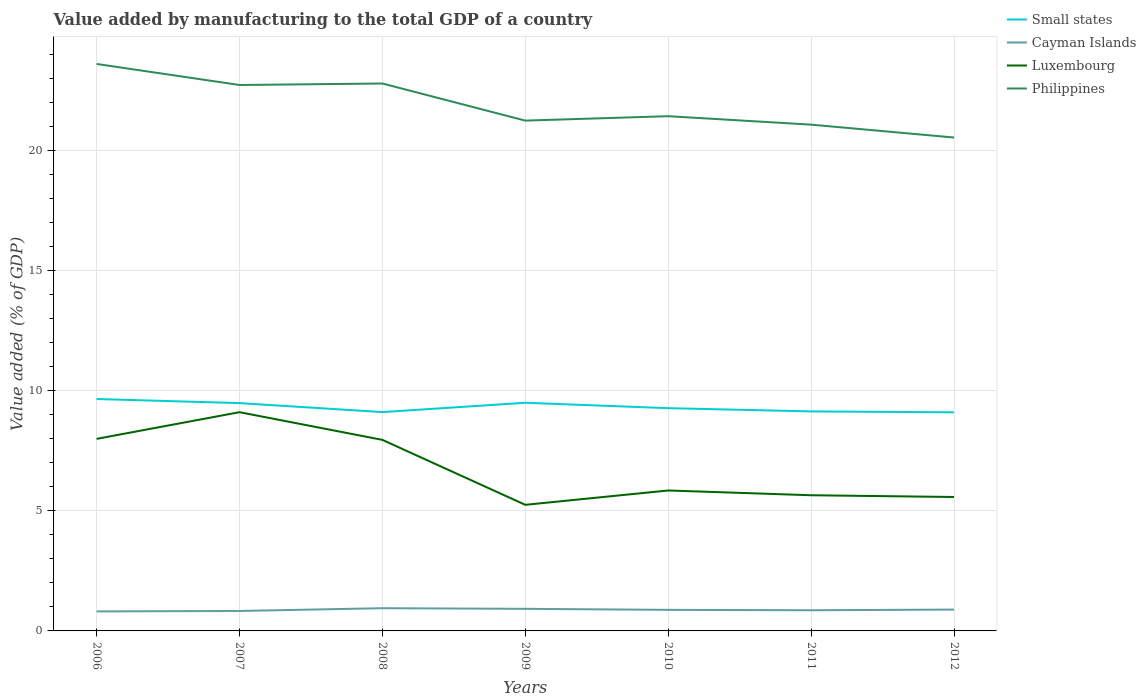How many different coloured lines are there?
Make the answer very short. 4. Does the line corresponding to Cayman Islands intersect with the line corresponding to Luxembourg?
Provide a succinct answer. No. Across all years, what is the maximum value added by manufacturing to the total GDP in Small states?
Keep it short and to the point. 9.11. What is the total value added by manufacturing to the total GDP in Cayman Islands in the graph?
Your answer should be very brief. -0.11. What is the difference between the highest and the second highest value added by manufacturing to the total GDP in Small states?
Ensure brevity in your answer.  0.55. Are the values on the major ticks of Y-axis written in scientific E-notation?
Your response must be concise. No. Does the graph contain any zero values?
Provide a succinct answer. No. Does the graph contain grids?
Provide a succinct answer. Yes. Where does the legend appear in the graph?
Offer a very short reply. Top right. How many legend labels are there?
Ensure brevity in your answer.  4. How are the legend labels stacked?
Keep it short and to the point. Vertical. What is the title of the graph?
Keep it short and to the point. Value added by manufacturing to the total GDP of a country. What is the label or title of the Y-axis?
Make the answer very short. Value added (% of GDP). What is the Value added (% of GDP) of Small states in 2006?
Offer a very short reply. 9.66. What is the Value added (% of GDP) of Cayman Islands in 2006?
Your answer should be compact. 0.81. What is the Value added (% of GDP) in Luxembourg in 2006?
Offer a terse response. 8. What is the Value added (% of GDP) of Philippines in 2006?
Your response must be concise. 23.62. What is the Value added (% of GDP) of Small states in 2007?
Give a very brief answer. 9.49. What is the Value added (% of GDP) in Cayman Islands in 2007?
Ensure brevity in your answer.  0.83. What is the Value added (% of GDP) in Luxembourg in 2007?
Offer a terse response. 9.11. What is the Value added (% of GDP) in Philippines in 2007?
Give a very brief answer. 22.74. What is the Value added (% of GDP) in Small states in 2008?
Give a very brief answer. 9.12. What is the Value added (% of GDP) in Cayman Islands in 2008?
Give a very brief answer. 0.95. What is the Value added (% of GDP) in Luxembourg in 2008?
Your answer should be very brief. 7.96. What is the Value added (% of GDP) of Philippines in 2008?
Give a very brief answer. 22.81. What is the Value added (% of GDP) of Small states in 2009?
Ensure brevity in your answer.  9.51. What is the Value added (% of GDP) in Cayman Islands in 2009?
Your response must be concise. 0.92. What is the Value added (% of GDP) in Luxembourg in 2009?
Make the answer very short. 5.25. What is the Value added (% of GDP) in Philippines in 2009?
Ensure brevity in your answer.  21.26. What is the Value added (% of GDP) in Small states in 2010?
Keep it short and to the point. 9.28. What is the Value added (% of GDP) in Cayman Islands in 2010?
Your response must be concise. 0.88. What is the Value added (% of GDP) in Luxembourg in 2010?
Your answer should be very brief. 5.85. What is the Value added (% of GDP) of Philippines in 2010?
Your response must be concise. 21.44. What is the Value added (% of GDP) of Small states in 2011?
Provide a succinct answer. 9.15. What is the Value added (% of GDP) in Cayman Islands in 2011?
Make the answer very short. 0.86. What is the Value added (% of GDP) of Luxembourg in 2011?
Keep it short and to the point. 5.65. What is the Value added (% of GDP) in Philippines in 2011?
Your answer should be compact. 21.09. What is the Value added (% of GDP) in Small states in 2012?
Your answer should be compact. 9.11. What is the Value added (% of GDP) in Cayman Islands in 2012?
Ensure brevity in your answer.  0.89. What is the Value added (% of GDP) in Luxembourg in 2012?
Your answer should be compact. 5.58. What is the Value added (% of GDP) in Philippines in 2012?
Your response must be concise. 20.56. Across all years, what is the maximum Value added (% of GDP) in Small states?
Keep it short and to the point. 9.66. Across all years, what is the maximum Value added (% of GDP) in Cayman Islands?
Offer a very short reply. 0.95. Across all years, what is the maximum Value added (% of GDP) of Luxembourg?
Ensure brevity in your answer.  9.11. Across all years, what is the maximum Value added (% of GDP) of Philippines?
Offer a terse response. 23.62. Across all years, what is the minimum Value added (% of GDP) of Small states?
Keep it short and to the point. 9.11. Across all years, what is the minimum Value added (% of GDP) in Cayman Islands?
Your answer should be compact. 0.81. Across all years, what is the minimum Value added (% of GDP) of Luxembourg?
Provide a short and direct response. 5.25. Across all years, what is the minimum Value added (% of GDP) of Philippines?
Ensure brevity in your answer.  20.56. What is the total Value added (% of GDP) of Small states in the graph?
Ensure brevity in your answer.  65.31. What is the total Value added (% of GDP) in Cayman Islands in the graph?
Give a very brief answer. 6.14. What is the total Value added (% of GDP) in Luxembourg in the graph?
Your answer should be compact. 47.41. What is the total Value added (% of GDP) in Philippines in the graph?
Offer a very short reply. 153.53. What is the difference between the Value added (% of GDP) in Small states in 2006 and that in 2007?
Keep it short and to the point. 0.17. What is the difference between the Value added (% of GDP) of Cayman Islands in 2006 and that in 2007?
Your answer should be compact. -0.02. What is the difference between the Value added (% of GDP) of Luxembourg in 2006 and that in 2007?
Your response must be concise. -1.11. What is the difference between the Value added (% of GDP) in Philippines in 2006 and that in 2007?
Provide a short and direct response. 0.88. What is the difference between the Value added (% of GDP) in Small states in 2006 and that in 2008?
Keep it short and to the point. 0.54. What is the difference between the Value added (% of GDP) in Cayman Islands in 2006 and that in 2008?
Provide a short and direct response. -0.13. What is the difference between the Value added (% of GDP) in Luxembourg in 2006 and that in 2008?
Provide a short and direct response. 0.04. What is the difference between the Value added (% of GDP) in Philippines in 2006 and that in 2008?
Your response must be concise. 0.81. What is the difference between the Value added (% of GDP) in Small states in 2006 and that in 2009?
Ensure brevity in your answer.  0.16. What is the difference between the Value added (% of GDP) of Cayman Islands in 2006 and that in 2009?
Make the answer very short. -0.11. What is the difference between the Value added (% of GDP) of Luxembourg in 2006 and that in 2009?
Your response must be concise. 2.75. What is the difference between the Value added (% of GDP) in Philippines in 2006 and that in 2009?
Offer a very short reply. 2.36. What is the difference between the Value added (% of GDP) in Small states in 2006 and that in 2010?
Your response must be concise. 0.38. What is the difference between the Value added (% of GDP) of Cayman Islands in 2006 and that in 2010?
Your answer should be compact. -0.06. What is the difference between the Value added (% of GDP) of Luxembourg in 2006 and that in 2010?
Provide a short and direct response. 2.15. What is the difference between the Value added (% of GDP) in Philippines in 2006 and that in 2010?
Offer a terse response. 2.18. What is the difference between the Value added (% of GDP) in Small states in 2006 and that in 2011?
Your response must be concise. 0.52. What is the difference between the Value added (% of GDP) of Cayman Islands in 2006 and that in 2011?
Give a very brief answer. -0.05. What is the difference between the Value added (% of GDP) in Luxembourg in 2006 and that in 2011?
Your response must be concise. 2.35. What is the difference between the Value added (% of GDP) in Philippines in 2006 and that in 2011?
Offer a terse response. 2.53. What is the difference between the Value added (% of GDP) in Small states in 2006 and that in 2012?
Your answer should be very brief. 0.55. What is the difference between the Value added (% of GDP) in Cayman Islands in 2006 and that in 2012?
Offer a very short reply. -0.08. What is the difference between the Value added (% of GDP) in Luxembourg in 2006 and that in 2012?
Provide a succinct answer. 2.42. What is the difference between the Value added (% of GDP) in Philippines in 2006 and that in 2012?
Keep it short and to the point. 3.07. What is the difference between the Value added (% of GDP) in Small states in 2007 and that in 2008?
Provide a short and direct response. 0.38. What is the difference between the Value added (% of GDP) in Cayman Islands in 2007 and that in 2008?
Your answer should be very brief. -0.12. What is the difference between the Value added (% of GDP) of Luxembourg in 2007 and that in 2008?
Your response must be concise. 1.15. What is the difference between the Value added (% of GDP) of Philippines in 2007 and that in 2008?
Make the answer very short. -0.06. What is the difference between the Value added (% of GDP) of Small states in 2007 and that in 2009?
Keep it short and to the point. -0.01. What is the difference between the Value added (% of GDP) in Cayman Islands in 2007 and that in 2009?
Ensure brevity in your answer.  -0.09. What is the difference between the Value added (% of GDP) of Luxembourg in 2007 and that in 2009?
Provide a short and direct response. 3.86. What is the difference between the Value added (% of GDP) of Philippines in 2007 and that in 2009?
Your response must be concise. 1.48. What is the difference between the Value added (% of GDP) of Small states in 2007 and that in 2010?
Offer a terse response. 0.21. What is the difference between the Value added (% of GDP) in Cayman Islands in 2007 and that in 2010?
Offer a very short reply. -0.05. What is the difference between the Value added (% of GDP) in Luxembourg in 2007 and that in 2010?
Provide a short and direct response. 3.26. What is the difference between the Value added (% of GDP) in Philippines in 2007 and that in 2010?
Ensure brevity in your answer.  1.3. What is the difference between the Value added (% of GDP) in Small states in 2007 and that in 2011?
Offer a very short reply. 0.35. What is the difference between the Value added (% of GDP) of Cayman Islands in 2007 and that in 2011?
Your response must be concise. -0.03. What is the difference between the Value added (% of GDP) in Luxembourg in 2007 and that in 2011?
Give a very brief answer. 3.46. What is the difference between the Value added (% of GDP) of Philippines in 2007 and that in 2011?
Make the answer very short. 1.65. What is the difference between the Value added (% of GDP) of Small states in 2007 and that in 2012?
Provide a succinct answer. 0.38. What is the difference between the Value added (% of GDP) in Cayman Islands in 2007 and that in 2012?
Provide a short and direct response. -0.06. What is the difference between the Value added (% of GDP) in Luxembourg in 2007 and that in 2012?
Your response must be concise. 3.53. What is the difference between the Value added (% of GDP) in Philippines in 2007 and that in 2012?
Your answer should be compact. 2.19. What is the difference between the Value added (% of GDP) in Small states in 2008 and that in 2009?
Make the answer very short. -0.39. What is the difference between the Value added (% of GDP) in Cayman Islands in 2008 and that in 2009?
Make the answer very short. 0.03. What is the difference between the Value added (% of GDP) in Luxembourg in 2008 and that in 2009?
Your answer should be very brief. 2.71. What is the difference between the Value added (% of GDP) of Philippines in 2008 and that in 2009?
Make the answer very short. 1.55. What is the difference between the Value added (% of GDP) in Small states in 2008 and that in 2010?
Your answer should be very brief. -0.16. What is the difference between the Value added (% of GDP) of Cayman Islands in 2008 and that in 2010?
Keep it short and to the point. 0.07. What is the difference between the Value added (% of GDP) of Luxembourg in 2008 and that in 2010?
Provide a succinct answer. 2.11. What is the difference between the Value added (% of GDP) of Philippines in 2008 and that in 2010?
Keep it short and to the point. 1.36. What is the difference between the Value added (% of GDP) of Small states in 2008 and that in 2011?
Ensure brevity in your answer.  -0.03. What is the difference between the Value added (% of GDP) of Cayman Islands in 2008 and that in 2011?
Keep it short and to the point. 0.09. What is the difference between the Value added (% of GDP) of Luxembourg in 2008 and that in 2011?
Keep it short and to the point. 2.31. What is the difference between the Value added (% of GDP) in Philippines in 2008 and that in 2011?
Give a very brief answer. 1.71. What is the difference between the Value added (% of GDP) in Small states in 2008 and that in 2012?
Your answer should be very brief. 0.01. What is the difference between the Value added (% of GDP) in Cayman Islands in 2008 and that in 2012?
Provide a succinct answer. 0.06. What is the difference between the Value added (% of GDP) in Luxembourg in 2008 and that in 2012?
Give a very brief answer. 2.38. What is the difference between the Value added (% of GDP) of Philippines in 2008 and that in 2012?
Your answer should be very brief. 2.25. What is the difference between the Value added (% of GDP) of Small states in 2009 and that in 2010?
Provide a short and direct response. 0.23. What is the difference between the Value added (% of GDP) of Cayman Islands in 2009 and that in 2010?
Provide a succinct answer. 0.04. What is the difference between the Value added (% of GDP) in Luxembourg in 2009 and that in 2010?
Make the answer very short. -0.6. What is the difference between the Value added (% of GDP) of Philippines in 2009 and that in 2010?
Provide a short and direct response. -0.18. What is the difference between the Value added (% of GDP) of Small states in 2009 and that in 2011?
Your response must be concise. 0.36. What is the difference between the Value added (% of GDP) in Cayman Islands in 2009 and that in 2011?
Your answer should be very brief. 0.06. What is the difference between the Value added (% of GDP) in Luxembourg in 2009 and that in 2011?
Make the answer very short. -0.4. What is the difference between the Value added (% of GDP) of Philippines in 2009 and that in 2011?
Make the answer very short. 0.17. What is the difference between the Value added (% of GDP) in Small states in 2009 and that in 2012?
Provide a succinct answer. 0.4. What is the difference between the Value added (% of GDP) of Cayman Islands in 2009 and that in 2012?
Keep it short and to the point. 0.03. What is the difference between the Value added (% of GDP) of Luxembourg in 2009 and that in 2012?
Keep it short and to the point. -0.33. What is the difference between the Value added (% of GDP) of Philippines in 2009 and that in 2012?
Your answer should be very brief. 0.7. What is the difference between the Value added (% of GDP) in Small states in 2010 and that in 2011?
Ensure brevity in your answer.  0.14. What is the difference between the Value added (% of GDP) of Cayman Islands in 2010 and that in 2011?
Give a very brief answer. 0.02. What is the difference between the Value added (% of GDP) of Luxembourg in 2010 and that in 2011?
Your response must be concise. 0.2. What is the difference between the Value added (% of GDP) in Philippines in 2010 and that in 2011?
Give a very brief answer. 0.35. What is the difference between the Value added (% of GDP) of Small states in 2010 and that in 2012?
Your answer should be very brief. 0.17. What is the difference between the Value added (% of GDP) in Cayman Islands in 2010 and that in 2012?
Offer a terse response. -0.01. What is the difference between the Value added (% of GDP) of Luxembourg in 2010 and that in 2012?
Give a very brief answer. 0.27. What is the difference between the Value added (% of GDP) in Philippines in 2010 and that in 2012?
Provide a short and direct response. 0.89. What is the difference between the Value added (% of GDP) in Small states in 2011 and that in 2012?
Offer a terse response. 0.04. What is the difference between the Value added (% of GDP) of Cayman Islands in 2011 and that in 2012?
Your answer should be compact. -0.03. What is the difference between the Value added (% of GDP) of Luxembourg in 2011 and that in 2012?
Make the answer very short. 0.07. What is the difference between the Value added (% of GDP) in Philippines in 2011 and that in 2012?
Offer a terse response. 0.54. What is the difference between the Value added (% of GDP) of Small states in 2006 and the Value added (% of GDP) of Cayman Islands in 2007?
Your answer should be very brief. 8.83. What is the difference between the Value added (% of GDP) in Small states in 2006 and the Value added (% of GDP) in Luxembourg in 2007?
Offer a very short reply. 0.55. What is the difference between the Value added (% of GDP) in Small states in 2006 and the Value added (% of GDP) in Philippines in 2007?
Ensure brevity in your answer.  -13.08. What is the difference between the Value added (% of GDP) in Cayman Islands in 2006 and the Value added (% of GDP) in Luxembourg in 2007?
Provide a succinct answer. -8.3. What is the difference between the Value added (% of GDP) in Cayman Islands in 2006 and the Value added (% of GDP) in Philippines in 2007?
Make the answer very short. -21.93. What is the difference between the Value added (% of GDP) of Luxembourg in 2006 and the Value added (% of GDP) of Philippines in 2007?
Your answer should be compact. -14.74. What is the difference between the Value added (% of GDP) in Small states in 2006 and the Value added (% of GDP) in Cayman Islands in 2008?
Provide a succinct answer. 8.71. What is the difference between the Value added (% of GDP) in Small states in 2006 and the Value added (% of GDP) in Luxembourg in 2008?
Your answer should be very brief. 1.7. What is the difference between the Value added (% of GDP) in Small states in 2006 and the Value added (% of GDP) in Philippines in 2008?
Ensure brevity in your answer.  -13.15. What is the difference between the Value added (% of GDP) in Cayman Islands in 2006 and the Value added (% of GDP) in Luxembourg in 2008?
Your answer should be compact. -7.15. What is the difference between the Value added (% of GDP) of Cayman Islands in 2006 and the Value added (% of GDP) of Philippines in 2008?
Ensure brevity in your answer.  -21.99. What is the difference between the Value added (% of GDP) of Luxembourg in 2006 and the Value added (% of GDP) of Philippines in 2008?
Keep it short and to the point. -14.81. What is the difference between the Value added (% of GDP) in Small states in 2006 and the Value added (% of GDP) in Cayman Islands in 2009?
Make the answer very short. 8.74. What is the difference between the Value added (% of GDP) in Small states in 2006 and the Value added (% of GDP) in Luxembourg in 2009?
Keep it short and to the point. 4.41. What is the difference between the Value added (% of GDP) of Small states in 2006 and the Value added (% of GDP) of Philippines in 2009?
Ensure brevity in your answer.  -11.6. What is the difference between the Value added (% of GDP) in Cayman Islands in 2006 and the Value added (% of GDP) in Luxembourg in 2009?
Provide a short and direct response. -4.44. What is the difference between the Value added (% of GDP) in Cayman Islands in 2006 and the Value added (% of GDP) in Philippines in 2009?
Your answer should be very brief. -20.45. What is the difference between the Value added (% of GDP) of Luxembourg in 2006 and the Value added (% of GDP) of Philippines in 2009?
Ensure brevity in your answer.  -13.26. What is the difference between the Value added (% of GDP) in Small states in 2006 and the Value added (% of GDP) in Cayman Islands in 2010?
Provide a short and direct response. 8.78. What is the difference between the Value added (% of GDP) of Small states in 2006 and the Value added (% of GDP) of Luxembourg in 2010?
Ensure brevity in your answer.  3.81. What is the difference between the Value added (% of GDP) in Small states in 2006 and the Value added (% of GDP) in Philippines in 2010?
Offer a very short reply. -11.78. What is the difference between the Value added (% of GDP) of Cayman Islands in 2006 and the Value added (% of GDP) of Luxembourg in 2010?
Your answer should be very brief. -5.04. What is the difference between the Value added (% of GDP) of Cayman Islands in 2006 and the Value added (% of GDP) of Philippines in 2010?
Offer a terse response. -20.63. What is the difference between the Value added (% of GDP) in Luxembourg in 2006 and the Value added (% of GDP) in Philippines in 2010?
Provide a short and direct response. -13.44. What is the difference between the Value added (% of GDP) of Small states in 2006 and the Value added (% of GDP) of Cayman Islands in 2011?
Offer a very short reply. 8.8. What is the difference between the Value added (% of GDP) in Small states in 2006 and the Value added (% of GDP) in Luxembourg in 2011?
Offer a terse response. 4.01. What is the difference between the Value added (% of GDP) of Small states in 2006 and the Value added (% of GDP) of Philippines in 2011?
Provide a succinct answer. -11.43. What is the difference between the Value added (% of GDP) of Cayman Islands in 2006 and the Value added (% of GDP) of Luxembourg in 2011?
Your response must be concise. -4.84. What is the difference between the Value added (% of GDP) in Cayman Islands in 2006 and the Value added (% of GDP) in Philippines in 2011?
Make the answer very short. -20.28. What is the difference between the Value added (% of GDP) of Luxembourg in 2006 and the Value added (% of GDP) of Philippines in 2011?
Your response must be concise. -13.09. What is the difference between the Value added (% of GDP) of Small states in 2006 and the Value added (% of GDP) of Cayman Islands in 2012?
Your response must be concise. 8.77. What is the difference between the Value added (% of GDP) of Small states in 2006 and the Value added (% of GDP) of Luxembourg in 2012?
Offer a terse response. 4.08. What is the difference between the Value added (% of GDP) in Small states in 2006 and the Value added (% of GDP) in Philippines in 2012?
Give a very brief answer. -10.89. What is the difference between the Value added (% of GDP) in Cayman Islands in 2006 and the Value added (% of GDP) in Luxembourg in 2012?
Offer a very short reply. -4.77. What is the difference between the Value added (% of GDP) in Cayman Islands in 2006 and the Value added (% of GDP) in Philippines in 2012?
Your answer should be compact. -19.74. What is the difference between the Value added (% of GDP) of Luxembourg in 2006 and the Value added (% of GDP) of Philippines in 2012?
Your answer should be compact. -12.55. What is the difference between the Value added (% of GDP) of Small states in 2007 and the Value added (% of GDP) of Cayman Islands in 2008?
Keep it short and to the point. 8.55. What is the difference between the Value added (% of GDP) in Small states in 2007 and the Value added (% of GDP) in Luxembourg in 2008?
Ensure brevity in your answer.  1.53. What is the difference between the Value added (% of GDP) in Small states in 2007 and the Value added (% of GDP) in Philippines in 2008?
Ensure brevity in your answer.  -13.31. What is the difference between the Value added (% of GDP) in Cayman Islands in 2007 and the Value added (% of GDP) in Luxembourg in 2008?
Ensure brevity in your answer.  -7.13. What is the difference between the Value added (% of GDP) in Cayman Islands in 2007 and the Value added (% of GDP) in Philippines in 2008?
Ensure brevity in your answer.  -21.98. What is the difference between the Value added (% of GDP) of Luxembourg in 2007 and the Value added (% of GDP) of Philippines in 2008?
Your answer should be compact. -13.69. What is the difference between the Value added (% of GDP) in Small states in 2007 and the Value added (% of GDP) in Cayman Islands in 2009?
Your response must be concise. 8.57. What is the difference between the Value added (% of GDP) of Small states in 2007 and the Value added (% of GDP) of Luxembourg in 2009?
Provide a short and direct response. 4.24. What is the difference between the Value added (% of GDP) of Small states in 2007 and the Value added (% of GDP) of Philippines in 2009?
Ensure brevity in your answer.  -11.77. What is the difference between the Value added (% of GDP) of Cayman Islands in 2007 and the Value added (% of GDP) of Luxembourg in 2009?
Your response must be concise. -4.42. What is the difference between the Value added (% of GDP) of Cayman Islands in 2007 and the Value added (% of GDP) of Philippines in 2009?
Provide a short and direct response. -20.43. What is the difference between the Value added (% of GDP) in Luxembourg in 2007 and the Value added (% of GDP) in Philippines in 2009?
Offer a terse response. -12.15. What is the difference between the Value added (% of GDP) in Small states in 2007 and the Value added (% of GDP) in Cayman Islands in 2010?
Your answer should be very brief. 8.61. What is the difference between the Value added (% of GDP) in Small states in 2007 and the Value added (% of GDP) in Luxembourg in 2010?
Give a very brief answer. 3.64. What is the difference between the Value added (% of GDP) of Small states in 2007 and the Value added (% of GDP) of Philippines in 2010?
Provide a short and direct response. -11.95. What is the difference between the Value added (% of GDP) in Cayman Islands in 2007 and the Value added (% of GDP) in Luxembourg in 2010?
Offer a terse response. -5.02. What is the difference between the Value added (% of GDP) of Cayman Islands in 2007 and the Value added (% of GDP) of Philippines in 2010?
Your answer should be very brief. -20.61. What is the difference between the Value added (% of GDP) of Luxembourg in 2007 and the Value added (% of GDP) of Philippines in 2010?
Provide a succinct answer. -12.33. What is the difference between the Value added (% of GDP) in Small states in 2007 and the Value added (% of GDP) in Cayman Islands in 2011?
Your response must be concise. 8.63. What is the difference between the Value added (% of GDP) of Small states in 2007 and the Value added (% of GDP) of Luxembourg in 2011?
Offer a very short reply. 3.84. What is the difference between the Value added (% of GDP) in Small states in 2007 and the Value added (% of GDP) in Philippines in 2011?
Ensure brevity in your answer.  -11.6. What is the difference between the Value added (% of GDP) of Cayman Islands in 2007 and the Value added (% of GDP) of Luxembourg in 2011?
Your answer should be very brief. -4.82. What is the difference between the Value added (% of GDP) of Cayman Islands in 2007 and the Value added (% of GDP) of Philippines in 2011?
Provide a short and direct response. -20.26. What is the difference between the Value added (% of GDP) of Luxembourg in 2007 and the Value added (% of GDP) of Philippines in 2011?
Your response must be concise. -11.98. What is the difference between the Value added (% of GDP) of Small states in 2007 and the Value added (% of GDP) of Cayman Islands in 2012?
Keep it short and to the point. 8.6. What is the difference between the Value added (% of GDP) of Small states in 2007 and the Value added (% of GDP) of Luxembourg in 2012?
Offer a very short reply. 3.91. What is the difference between the Value added (% of GDP) of Small states in 2007 and the Value added (% of GDP) of Philippines in 2012?
Your answer should be very brief. -11.06. What is the difference between the Value added (% of GDP) in Cayman Islands in 2007 and the Value added (% of GDP) in Luxembourg in 2012?
Ensure brevity in your answer.  -4.75. What is the difference between the Value added (% of GDP) in Cayman Islands in 2007 and the Value added (% of GDP) in Philippines in 2012?
Provide a succinct answer. -19.72. What is the difference between the Value added (% of GDP) of Luxembourg in 2007 and the Value added (% of GDP) of Philippines in 2012?
Keep it short and to the point. -11.44. What is the difference between the Value added (% of GDP) in Small states in 2008 and the Value added (% of GDP) in Cayman Islands in 2009?
Your answer should be very brief. 8.2. What is the difference between the Value added (% of GDP) in Small states in 2008 and the Value added (% of GDP) in Luxembourg in 2009?
Keep it short and to the point. 3.86. What is the difference between the Value added (% of GDP) in Small states in 2008 and the Value added (% of GDP) in Philippines in 2009?
Give a very brief answer. -12.14. What is the difference between the Value added (% of GDP) of Cayman Islands in 2008 and the Value added (% of GDP) of Luxembourg in 2009?
Give a very brief answer. -4.31. What is the difference between the Value added (% of GDP) of Cayman Islands in 2008 and the Value added (% of GDP) of Philippines in 2009?
Ensure brevity in your answer.  -20.31. What is the difference between the Value added (% of GDP) in Luxembourg in 2008 and the Value added (% of GDP) in Philippines in 2009?
Give a very brief answer. -13.3. What is the difference between the Value added (% of GDP) of Small states in 2008 and the Value added (% of GDP) of Cayman Islands in 2010?
Your answer should be very brief. 8.24. What is the difference between the Value added (% of GDP) in Small states in 2008 and the Value added (% of GDP) in Luxembourg in 2010?
Provide a succinct answer. 3.27. What is the difference between the Value added (% of GDP) of Small states in 2008 and the Value added (% of GDP) of Philippines in 2010?
Your answer should be compact. -12.33. What is the difference between the Value added (% of GDP) in Cayman Islands in 2008 and the Value added (% of GDP) in Luxembourg in 2010?
Your response must be concise. -4.9. What is the difference between the Value added (% of GDP) of Cayman Islands in 2008 and the Value added (% of GDP) of Philippines in 2010?
Your answer should be compact. -20.5. What is the difference between the Value added (% of GDP) of Luxembourg in 2008 and the Value added (% of GDP) of Philippines in 2010?
Your answer should be very brief. -13.49. What is the difference between the Value added (% of GDP) in Small states in 2008 and the Value added (% of GDP) in Cayman Islands in 2011?
Keep it short and to the point. 8.26. What is the difference between the Value added (% of GDP) in Small states in 2008 and the Value added (% of GDP) in Luxembourg in 2011?
Ensure brevity in your answer.  3.46. What is the difference between the Value added (% of GDP) of Small states in 2008 and the Value added (% of GDP) of Philippines in 2011?
Give a very brief answer. -11.98. What is the difference between the Value added (% of GDP) of Cayman Islands in 2008 and the Value added (% of GDP) of Luxembourg in 2011?
Give a very brief answer. -4.71. What is the difference between the Value added (% of GDP) in Cayman Islands in 2008 and the Value added (% of GDP) in Philippines in 2011?
Provide a succinct answer. -20.15. What is the difference between the Value added (% of GDP) of Luxembourg in 2008 and the Value added (% of GDP) of Philippines in 2011?
Provide a succinct answer. -13.13. What is the difference between the Value added (% of GDP) in Small states in 2008 and the Value added (% of GDP) in Cayman Islands in 2012?
Give a very brief answer. 8.23. What is the difference between the Value added (% of GDP) of Small states in 2008 and the Value added (% of GDP) of Luxembourg in 2012?
Your response must be concise. 3.54. What is the difference between the Value added (% of GDP) of Small states in 2008 and the Value added (% of GDP) of Philippines in 2012?
Provide a short and direct response. -11.44. What is the difference between the Value added (% of GDP) in Cayman Islands in 2008 and the Value added (% of GDP) in Luxembourg in 2012?
Your answer should be very brief. -4.63. What is the difference between the Value added (% of GDP) of Cayman Islands in 2008 and the Value added (% of GDP) of Philippines in 2012?
Give a very brief answer. -19.61. What is the difference between the Value added (% of GDP) of Luxembourg in 2008 and the Value added (% of GDP) of Philippines in 2012?
Keep it short and to the point. -12.6. What is the difference between the Value added (% of GDP) of Small states in 2009 and the Value added (% of GDP) of Cayman Islands in 2010?
Ensure brevity in your answer.  8.63. What is the difference between the Value added (% of GDP) in Small states in 2009 and the Value added (% of GDP) in Luxembourg in 2010?
Your answer should be compact. 3.65. What is the difference between the Value added (% of GDP) in Small states in 2009 and the Value added (% of GDP) in Philippines in 2010?
Offer a very short reply. -11.94. What is the difference between the Value added (% of GDP) in Cayman Islands in 2009 and the Value added (% of GDP) in Luxembourg in 2010?
Keep it short and to the point. -4.93. What is the difference between the Value added (% of GDP) of Cayman Islands in 2009 and the Value added (% of GDP) of Philippines in 2010?
Offer a terse response. -20.52. What is the difference between the Value added (% of GDP) of Luxembourg in 2009 and the Value added (% of GDP) of Philippines in 2010?
Your response must be concise. -16.19. What is the difference between the Value added (% of GDP) in Small states in 2009 and the Value added (% of GDP) in Cayman Islands in 2011?
Your answer should be very brief. 8.64. What is the difference between the Value added (% of GDP) in Small states in 2009 and the Value added (% of GDP) in Luxembourg in 2011?
Your answer should be very brief. 3.85. What is the difference between the Value added (% of GDP) in Small states in 2009 and the Value added (% of GDP) in Philippines in 2011?
Offer a terse response. -11.59. What is the difference between the Value added (% of GDP) of Cayman Islands in 2009 and the Value added (% of GDP) of Luxembourg in 2011?
Provide a succinct answer. -4.73. What is the difference between the Value added (% of GDP) in Cayman Islands in 2009 and the Value added (% of GDP) in Philippines in 2011?
Keep it short and to the point. -20.17. What is the difference between the Value added (% of GDP) in Luxembourg in 2009 and the Value added (% of GDP) in Philippines in 2011?
Your response must be concise. -15.84. What is the difference between the Value added (% of GDP) of Small states in 2009 and the Value added (% of GDP) of Cayman Islands in 2012?
Offer a very short reply. 8.62. What is the difference between the Value added (% of GDP) in Small states in 2009 and the Value added (% of GDP) in Luxembourg in 2012?
Offer a very short reply. 3.93. What is the difference between the Value added (% of GDP) of Small states in 2009 and the Value added (% of GDP) of Philippines in 2012?
Your answer should be compact. -11.05. What is the difference between the Value added (% of GDP) in Cayman Islands in 2009 and the Value added (% of GDP) in Luxembourg in 2012?
Offer a terse response. -4.66. What is the difference between the Value added (% of GDP) of Cayman Islands in 2009 and the Value added (% of GDP) of Philippines in 2012?
Provide a short and direct response. -19.64. What is the difference between the Value added (% of GDP) in Luxembourg in 2009 and the Value added (% of GDP) in Philippines in 2012?
Provide a short and direct response. -15.3. What is the difference between the Value added (% of GDP) in Small states in 2010 and the Value added (% of GDP) in Cayman Islands in 2011?
Provide a succinct answer. 8.42. What is the difference between the Value added (% of GDP) in Small states in 2010 and the Value added (% of GDP) in Luxembourg in 2011?
Ensure brevity in your answer.  3.63. What is the difference between the Value added (% of GDP) in Small states in 2010 and the Value added (% of GDP) in Philippines in 2011?
Make the answer very short. -11.81. What is the difference between the Value added (% of GDP) in Cayman Islands in 2010 and the Value added (% of GDP) in Luxembourg in 2011?
Ensure brevity in your answer.  -4.77. What is the difference between the Value added (% of GDP) of Cayman Islands in 2010 and the Value added (% of GDP) of Philippines in 2011?
Make the answer very short. -20.22. What is the difference between the Value added (% of GDP) in Luxembourg in 2010 and the Value added (% of GDP) in Philippines in 2011?
Your answer should be very brief. -15.24. What is the difference between the Value added (% of GDP) of Small states in 2010 and the Value added (% of GDP) of Cayman Islands in 2012?
Offer a very short reply. 8.39. What is the difference between the Value added (% of GDP) of Small states in 2010 and the Value added (% of GDP) of Luxembourg in 2012?
Keep it short and to the point. 3.7. What is the difference between the Value added (% of GDP) in Small states in 2010 and the Value added (% of GDP) in Philippines in 2012?
Provide a short and direct response. -11.28. What is the difference between the Value added (% of GDP) in Cayman Islands in 2010 and the Value added (% of GDP) in Luxembourg in 2012?
Provide a succinct answer. -4.7. What is the difference between the Value added (% of GDP) in Cayman Islands in 2010 and the Value added (% of GDP) in Philippines in 2012?
Your answer should be very brief. -19.68. What is the difference between the Value added (% of GDP) in Luxembourg in 2010 and the Value added (% of GDP) in Philippines in 2012?
Your response must be concise. -14.7. What is the difference between the Value added (% of GDP) in Small states in 2011 and the Value added (% of GDP) in Cayman Islands in 2012?
Provide a short and direct response. 8.26. What is the difference between the Value added (% of GDP) in Small states in 2011 and the Value added (% of GDP) in Luxembourg in 2012?
Your response must be concise. 3.57. What is the difference between the Value added (% of GDP) in Small states in 2011 and the Value added (% of GDP) in Philippines in 2012?
Your answer should be very brief. -11.41. What is the difference between the Value added (% of GDP) in Cayman Islands in 2011 and the Value added (% of GDP) in Luxembourg in 2012?
Provide a succinct answer. -4.72. What is the difference between the Value added (% of GDP) in Cayman Islands in 2011 and the Value added (% of GDP) in Philippines in 2012?
Offer a terse response. -19.69. What is the difference between the Value added (% of GDP) of Luxembourg in 2011 and the Value added (% of GDP) of Philippines in 2012?
Your response must be concise. -14.9. What is the average Value added (% of GDP) in Small states per year?
Give a very brief answer. 9.33. What is the average Value added (% of GDP) in Cayman Islands per year?
Your response must be concise. 0.88. What is the average Value added (% of GDP) in Luxembourg per year?
Give a very brief answer. 6.77. What is the average Value added (% of GDP) of Philippines per year?
Offer a terse response. 21.93. In the year 2006, what is the difference between the Value added (% of GDP) of Small states and Value added (% of GDP) of Cayman Islands?
Ensure brevity in your answer.  8.85. In the year 2006, what is the difference between the Value added (% of GDP) in Small states and Value added (% of GDP) in Luxembourg?
Provide a short and direct response. 1.66. In the year 2006, what is the difference between the Value added (% of GDP) in Small states and Value added (% of GDP) in Philippines?
Ensure brevity in your answer.  -13.96. In the year 2006, what is the difference between the Value added (% of GDP) of Cayman Islands and Value added (% of GDP) of Luxembourg?
Offer a terse response. -7.19. In the year 2006, what is the difference between the Value added (% of GDP) in Cayman Islands and Value added (% of GDP) in Philippines?
Offer a very short reply. -22.81. In the year 2006, what is the difference between the Value added (% of GDP) in Luxembourg and Value added (% of GDP) in Philippines?
Provide a short and direct response. -15.62. In the year 2007, what is the difference between the Value added (% of GDP) of Small states and Value added (% of GDP) of Cayman Islands?
Give a very brief answer. 8.66. In the year 2007, what is the difference between the Value added (% of GDP) in Small states and Value added (% of GDP) in Luxembourg?
Give a very brief answer. 0.38. In the year 2007, what is the difference between the Value added (% of GDP) in Small states and Value added (% of GDP) in Philippines?
Provide a succinct answer. -13.25. In the year 2007, what is the difference between the Value added (% of GDP) of Cayman Islands and Value added (% of GDP) of Luxembourg?
Offer a very short reply. -8.28. In the year 2007, what is the difference between the Value added (% of GDP) in Cayman Islands and Value added (% of GDP) in Philippines?
Keep it short and to the point. -21.91. In the year 2007, what is the difference between the Value added (% of GDP) of Luxembourg and Value added (% of GDP) of Philippines?
Provide a succinct answer. -13.63. In the year 2008, what is the difference between the Value added (% of GDP) of Small states and Value added (% of GDP) of Cayman Islands?
Your answer should be compact. 8.17. In the year 2008, what is the difference between the Value added (% of GDP) in Small states and Value added (% of GDP) in Luxembourg?
Provide a short and direct response. 1.16. In the year 2008, what is the difference between the Value added (% of GDP) in Small states and Value added (% of GDP) in Philippines?
Offer a terse response. -13.69. In the year 2008, what is the difference between the Value added (% of GDP) of Cayman Islands and Value added (% of GDP) of Luxembourg?
Ensure brevity in your answer.  -7.01. In the year 2008, what is the difference between the Value added (% of GDP) of Cayman Islands and Value added (% of GDP) of Philippines?
Your answer should be very brief. -21.86. In the year 2008, what is the difference between the Value added (% of GDP) of Luxembourg and Value added (% of GDP) of Philippines?
Your answer should be very brief. -14.85. In the year 2009, what is the difference between the Value added (% of GDP) in Small states and Value added (% of GDP) in Cayman Islands?
Provide a succinct answer. 8.59. In the year 2009, what is the difference between the Value added (% of GDP) in Small states and Value added (% of GDP) in Luxembourg?
Ensure brevity in your answer.  4.25. In the year 2009, what is the difference between the Value added (% of GDP) of Small states and Value added (% of GDP) of Philippines?
Keep it short and to the point. -11.75. In the year 2009, what is the difference between the Value added (% of GDP) in Cayman Islands and Value added (% of GDP) in Luxembourg?
Offer a terse response. -4.33. In the year 2009, what is the difference between the Value added (% of GDP) in Cayman Islands and Value added (% of GDP) in Philippines?
Provide a short and direct response. -20.34. In the year 2009, what is the difference between the Value added (% of GDP) in Luxembourg and Value added (% of GDP) in Philippines?
Your response must be concise. -16.01. In the year 2010, what is the difference between the Value added (% of GDP) in Small states and Value added (% of GDP) in Cayman Islands?
Offer a terse response. 8.4. In the year 2010, what is the difference between the Value added (% of GDP) in Small states and Value added (% of GDP) in Luxembourg?
Your response must be concise. 3.43. In the year 2010, what is the difference between the Value added (% of GDP) in Small states and Value added (% of GDP) in Philippines?
Your answer should be compact. -12.16. In the year 2010, what is the difference between the Value added (% of GDP) in Cayman Islands and Value added (% of GDP) in Luxembourg?
Offer a very short reply. -4.97. In the year 2010, what is the difference between the Value added (% of GDP) in Cayman Islands and Value added (% of GDP) in Philippines?
Offer a terse response. -20.57. In the year 2010, what is the difference between the Value added (% of GDP) in Luxembourg and Value added (% of GDP) in Philippines?
Your response must be concise. -15.59. In the year 2011, what is the difference between the Value added (% of GDP) in Small states and Value added (% of GDP) in Cayman Islands?
Provide a succinct answer. 8.28. In the year 2011, what is the difference between the Value added (% of GDP) of Small states and Value added (% of GDP) of Luxembourg?
Keep it short and to the point. 3.49. In the year 2011, what is the difference between the Value added (% of GDP) of Small states and Value added (% of GDP) of Philippines?
Your answer should be very brief. -11.95. In the year 2011, what is the difference between the Value added (% of GDP) in Cayman Islands and Value added (% of GDP) in Luxembourg?
Ensure brevity in your answer.  -4.79. In the year 2011, what is the difference between the Value added (% of GDP) of Cayman Islands and Value added (% of GDP) of Philippines?
Your answer should be very brief. -20.23. In the year 2011, what is the difference between the Value added (% of GDP) in Luxembourg and Value added (% of GDP) in Philippines?
Your response must be concise. -15.44. In the year 2012, what is the difference between the Value added (% of GDP) of Small states and Value added (% of GDP) of Cayman Islands?
Provide a succinct answer. 8.22. In the year 2012, what is the difference between the Value added (% of GDP) in Small states and Value added (% of GDP) in Luxembourg?
Provide a short and direct response. 3.53. In the year 2012, what is the difference between the Value added (% of GDP) in Small states and Value added (% of GDP) in Philippines?
Keep it short and to the point. -11.45. In the year 2012, what is the difference between the Value added (% of GDP) in Cayman Islands and Value added (% of GDP) in Luxembourg?
Offer a terse response. -4.69. In the year 2012, what is the difference between the Value added (% of GDP) of Cayman Islands and Value added (% of GDP) of Philippines?
Ensure brevity in your answer.  -19.67. In the year 2012, what is the difference between the Value added (% of GDP) in Luxembourg and Value added (% of GDP) in Philippines?
Your answer should be very brief. -14.98. What is the ratio of the Value added (% of GDP) in Small states in 2006 to that in 2007?
Your answer should be compact. 1.02. What is the ratio of the Value added (% of GDP) in Luxembourg in 2006 to that in 2007?
Ensure brevity in your answer.  0.88. What is the ratio of the Value added (% of GDP) of Philippines in 2006 to that in 2007?
Your answer should be compact. 1.04. What is the ratio of the Value added (% of GDP) in Small states in 2006 to that in 2008?
Your response must be concise. 1.06. What is the ratio of the Value added (% of GDP) of Cayman Islands in 2006 to that in 2008?
Give a very brief answer. 0.86. What is the ratio of the Value added (% of GDP) in Luxembourg in 2006 to that in 2008?
Your answer should be compact. 1.01. What is the ratio of the Value added (% of GDP) in Philippines in 2006 to that in 2008?
Your response must be concise. 1.04. What is the ratio of the Value added (% of GDP) in Small states in 2006 to that in 2009?
Ensure brevity in your answer.  1.02. What is the ratio of the Value added (% of GDP) in Cayman Islands in 2006 to that in 2009?
Your answer should be very brief. 0.88. What is the ratio of the Value added (% of GDP) in Luxembourg in 2006 to that in 2009?
Ensure brevity in your answer.  1.52. What is the ratio of the Value added (% of GDP) in Philippines in 2006 to that in 2009?
Provide a short and direct response. 1.11. What is the ratio of the Value added (% of GDP) in Small states in 2006 to that in 2010?
Your response must be concise. 1.04. What is the ratio of the Value added (% of GDP) of Cayman Islands in 2006 to that in 2010?
Offer a terse response. 0.93. What is the ratio of the Value added (% of GDP) in Luxembourg in 2006 to that in 2010?
Make the answer very short. 1.37. What is the ratio of the Value added (% of GDP) in Philippines in 2006 to that in 2010?
Ensure brevity in your answer.  1.1. What is the ratio of the Value added (% of GDP) in Small states in 2006 to that in 2011?
Make the answer very short. 1.06. What is the ratio of the Value added (% of GDP) of Cayman Islands in 2006 to that in 2011?
Provide a succinct answer. 0.94. What is the ratio of the Value added (% of GDP) of Luxembourg in 2006 to that in 2011?
Offer a very short reply. 1.42. What is the ratio of the Value added (% of GDP) in Philippines in 2006 to that in 2011?
Your response must be concise. 1.12. What is the ratio of the Value added (% of GDP) in Small states in 2006 to that in 2012?
Your answer should be compact. 1.06. What is the ratio of the Value added (% of GDP) of Cayman Islands in 2006 to that in 2012?
Keep it short and to the point. 0.91. What is the ratio of the Value added (% of GDP) of Luxembourg in 2006 to that in 2012?
Your answer should be very brief. 1.43. What is the ratio of the Value added (% of GDP) of Philippines in 2006 to that in 2012?
Offer a terse response. 1.15. What is the ratio of the Value added (% of GDP) in Small states in 2007 to that in 2008?
Give a very brief answer. 1.04. What is the ratio of the Value added (% of GDP) of Cayman Islands in 2007 to that in 2008?
Ensure brevity in your answer.  0.88. What is the ratio of the Value added (% of GDP) of Luxembourg in 2007 to that in 2008?
Keep it short and to the point. 1.15. What is the ratio of the Value added (% of GDP) of Philippines in 2007 to that in 2008?
Your response must be concise. 1. What is the ratio of the Value added (% of GDP) in Small states in 2007 to that in 2009?
Your response must be concise. 1. What is the ratio of the Value added (% of GDP) of Cayman Islands in 2007 to that in 2009?
Offer a very short reply. 0.9. What is the ratio of the Value added (% of GDP) in Luxembourg in 2007 to that in 2009?
Offer a very short reply. 1.73. What is the ratio of the Value added (% of GDP) in Philippines in 2007 to that in 2009?
Ensure brevity in your answer.  1.07. What is the ratio of the Value added (% of GDP) in Small states in 2007 to that in 2010?
Offer a very short reply. 1.02. What is the ratio of the Value added (% of GDP) in Cayman Islands in 2007 to that in 2010?
Offer a very short reply. 0.95. What is the ratio of the Value added (% of GDP) in Luxembourg in 2007 to that in 2010?
Provide a succinct answer. 1.56. What is the ratio of the Value added (% of GDP) of Philippines in 2007 to that in 2010?
Your answer should be compact. 1.06. What is the ratio of the Value added (% of GDP) in Small states in 2007 to that in 2011?
Ensure brevity in your answer.  1.04. What is the ratio of the Value added (% of GDP) in Cayman Islands in 2007 to that in 2011?
Offer a very short reply. 0.97. What is the ratio of the Value added (% of GDP) of Luxembourg in 2007 to that in 2011?
Your response must be concise. 1.61. What is the ratio of the Value added (% of GDP) in Philippines in 2007 to that in 2011?
Your answer should be compact. 1.08. What is the ratio of the Value added (% of GDP) in Small states in 2007 to that in 2012?
Ensure brevity in your answer.  1.04. What is the ratio of the Value added (% of GDP) in Cayman Islands in 2007 to that in 2012?
Provide a short and direct response. 0.94. What is the ratio of the Value added (% of GDP) of Luxembourg in 2007 to that in 2012?
Ensure brevity in your answer.  1.63. What is the ratio of the Value added (% of GDP) in Philippines in 2007 to that in 2012?
Provide a short and direct response. 1.11. What is the ratio of the Value added (% of GDP) of Small states in 2008 to that in 2009?
Your answer should be compact. 0.96. What is the ratio of the Value added (% of GDP) of Cayman Islands in 2008 to that in 2009?
Keep it short and to the point. 1.03. What is the ratio of the Value added (% of GDP) in Luxembourg in 2008 to that in 2009?
Provide a short and direct response. 1.51. What is the ratio of the Value added (% of GDP) in Philippines in 2008 to that in 2009?
Your answer should be very brief. 1.07. What is the ratio of the Value added (% of GDP) of Small states in 2008 to that in 2010?
Offer a very short reply. 0.98. What is the ratio of the Value added (% of GDP) in Cayman Islands in 2008 to that in 2010?
Offer a terse response. 1.08. What is the ratio of the Value added (% of GDP) in Luxembourg in 2008 to that in 2010?
Offer a terse response. 1.36. What is the ratio of the Value added (% of GDP) in Philippines in 2008 to that in 2010?
Give a very brief answer. 1.06. What is the ratio of the Value added (% of GDP) in Small states in 2008 to that in 2011?
Your answer should be compact. 1. What is the ratio of the Value added (% of GDP) of Cayman Islands in 2008 to that in 2011?
Ensure brevity in your answer.  1.1. What is the ratio of the Value added (% of GDP) of Luxembourg in 2008 to that in 2011?
Offer a very short reply. 1.41. What is the ratio of the Value added (% of GDP) in Philippines in 2008 to that in 2011?
Offer a very short reply. 1.08. What is the ratio of the Value added (% of GDP) of Cayman Islands in 2008 to that in 2012?
Offer a terse response. 1.06. What is the ratio of the Value added (% of GDP) of Luxembourg in 2008 to that in 2012?
Your answer should be compact. 1.43. What is the ratio of the Value added (% of GDP) of Philippines in 2008 to that in 2012?
Give a very brief answer. 1.11. What is the ratio of the Value added (% of GDP) in Small states in 2009 to that in 2010?
Your answer should be very brief. 1.02. What is the ratio of the Value added (% of GDP) of Cayman Islands in 2009 to that in 2010?
Offer a very short reply. 1.05. What is the ratio of the Value added (% of GDP) in Luxembourg in 2009 to that in 2010?
Provide a succinct answer. 0.9. What is the ratio of the Value added (% of GDP) of Small states in 2009 to that in 2011?
Your response must be concise. 1.04. What is the ratio of the Value added (% of GDP) of Cayman Islands in 2009 to that in 2011?
Keep it short and to the point. 1.07. What is the ratio of the Value added (% of GDP) in Luxembourg in 2009 to that in 2011?
Provide a short and direct response. 0.93. What is the ratio of the Value added (% of GDP) of Philippines in 2009 to that in 2011?
Give a very brief answer. 1.01. What is the ratio of the Value added (% of GDP) in Small states in 2009 to that in 2012?
Keep it short and to the point. 1.04. What is the ratio of the Value added (% of GDP) of Cayman Islands in 2009 to that in 2012?
Keep it short and to the point. 1.03. What is the ratio of the Value added (% of GDP) of Luxembourg in 2009 to that in 2012?
Keep it short and to the point. 0.94. What is the ratio of the Value added (% of GDP) in Philippines in 2009 to that in 2012?
Ensure brevity in your answer.  1.03. What is the ratio of the Value added (% of GDP) in Small states in 2010 to that in 2011?
Ensure brevity in your answer.  1.01. What is the ratio of the Value added (% of GDP) of Cayman Islands in 2010 to that in 2011?
Make the answer very short. 1.02. What is the ratio of the Value added (% of GDP) of Luxembourg in 2010 to that in 2011?
Make the answer very short. 1.04. What is the ratio of the Value added (% of GDP) of Philippines in 2010 to that in 2011?
Your answer should be compact. 1.02. What is the ratio of the Value added (% of GDP) of Cayman Islands in 2010 to that in 2012?
Make the answer very short. 0.99. What is the ratio of the Value added (% of GDP) of Luxembourg in 2010 to that in 2012?
Offer a very short reply. 1.05. What is the ratio of the Value added (% of GDP) of Philippines in 2010 to that in 2012?
Provide a short and direct response. 1.04. What is the ratio of the Value added (% of GDP) in Cayman Islands in 2011 to that in 2012?
Ensure brevity in your answer.  0.97. What is the ratio of the Value added (% of GDP) in Luxembourg in 2011 to that in 2012?
Ensure brevity in your answer.  1.01. What is the ratio of the Value added (% of GDP) in Philippines in 2011 to that in 2012?
Make the answer very short. 1.03. What is the difference between the highest and the second highest Value added (% of GDP) of Small states?
Offer a very short reply. 0.16. What is the difference between the highest and the second highest Value added (% of GDP) in Cayman Islands?
Your answer should be compact. 0.03. What is the difference between the highest and the second highest Value added (% of GDP) of Luxembourg?
Ensure brevity in your answer.  1.11. What is the difference between the highest and the second highest Value added (% of GDP) in Philippines?
Provide a short and direct response. 0.81. What is the difference between the highest and the lowest Value added (% of GDP) in Small states?
Keep it short and to the point. 0.55. What is the difference between the highest and the lowest Value added (% of GDP) in Cayman Islands?
Provide a succinct answer. 0.13. What is the difference between the highest and the lowest Value added (% of GDP) in Luxembourg?
Keep it short and to the point. 3.86. What is the difference between the highest and the lowest Value added (% of GDP) of Philippines?
Your answer should be very brief. 3.07. 